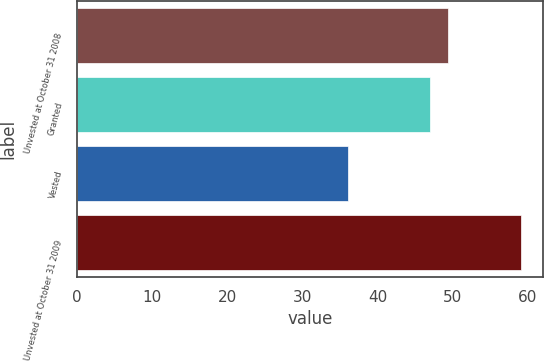Convert chart to OTSL. <chart><loc_0><loc_0><loc_500><loc_500><bar_chart><fcel>Unvested at October 31 2008<fcel>Granted<fcel>Vested<fcel>Unvested at October 31 2009<nl><fcel>49.3<fcel>47<fcel>36<fcel>59<nl></chart> 